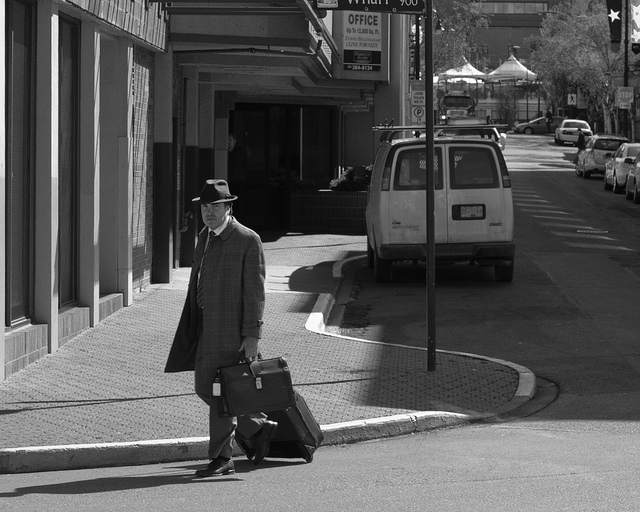<image>What is inside the bag? I am unsure of what is inside the bag. It could be clothes, papers or luggage. What instrument in with the luggage? I don't know which instrument is with the luggage. It could be a handbag, flute, trombone, trumpet, clarinet, saxophone or violin. What is inside the bag? I am not sure what is inside the bag. It can be clothes, papers, or luggage. What instrument in with the luggage? I am not sure. It can be seen 'handbag', 'flute', 'trombone', 'trumpet', 'clarinet', 'flute', 'saxophone', 'clarinet', or 'violin'. 